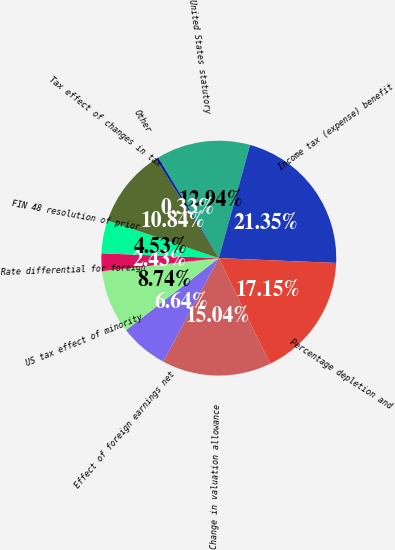Convert chart to OTSL. <chart><loc_0><loc_0><loc_500><loc_500><pie_chart><fcel>United States statutory<fcel>Income tax (expense) benefit<fcel>Percentage depletion and<fcel>Change in valuation allowance<fcel>Effect of foreign earnings net<fcel>US tax effect of minority<fcel>Rate differential for foreign<fcel>FIN 48 resolution of prior<fcel>Tax effect of changes in tax<fcel>Other<nl><fcel>12.94%<fcel>21.35%<fcel>17.15%<fcel>15.04%<fcel>6.64%<fcel>8.74%<fcel>2.43%<fcel>4.53%<fcel>10.84%<fcel>0.33%<nl></chart> 